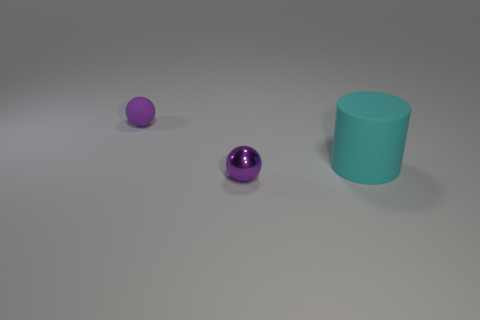Add 3 tiny yellow shiny cylinders. How many objects exist? 6 Subtract all balls. How many objects are left? 1 Subtract all big rubber cylinders. Subtract all purple things. How many objects are left? 0 Add 1 big cyan rubber cylinders. How many big cyan rubber cylinders are left? 2 Add 1 tiny purple balls. How many tiny purple balls exist? 3 Subtract 0 gray balls. How many objects are left? 3 